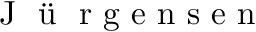<formula> <loc_0><loc_0><loc_500><loc_500>J \ddot { u } r g e n s e n</formula> 